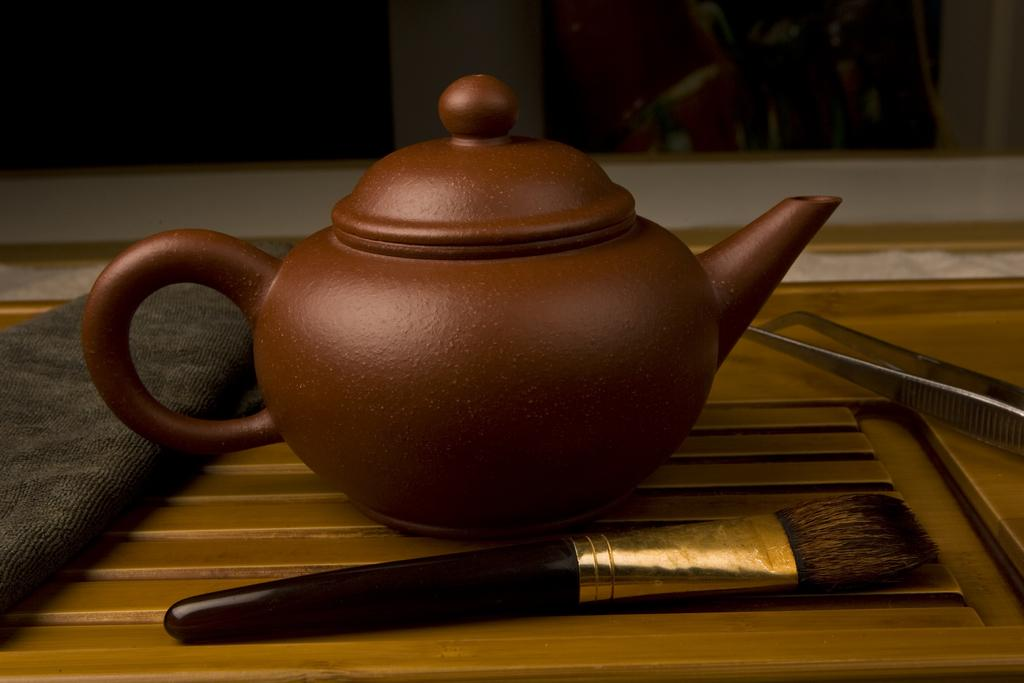What type of container is visible in the image? There is a tea pot in the image. What other objects can be seen on the tray? There is a brush, a cloth, and a metal object on the tray. What is the purpose of the brush and cloth? The brush and cloth may be used for cleaning or polishing the metal object. What can be seen on the wall in the image? There are frames on the wall in the image. What type of collar can be seen on the desk in the image? There is no collar or desk present in the image. How does the tongue of the person in the image taste the tea? There is no person or tongue visible in the image; it only shows objects on a tray and frames on the wall. 